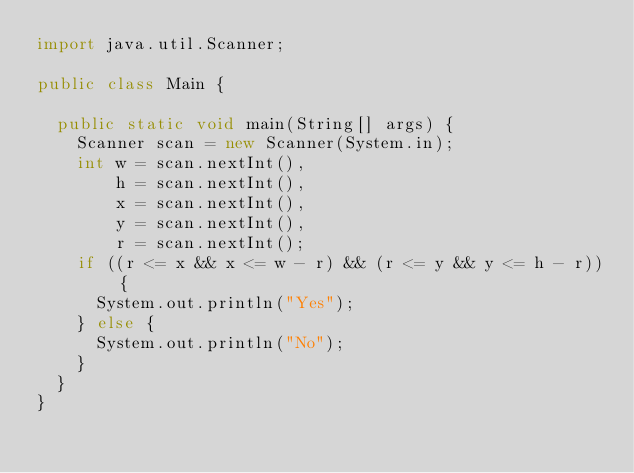<code> <loc_0><loc_0><loc_500><loc_500><_Java_>import java.util.Scanner;

public class Main {

  public static void main(String[] args) {
    Scanner scan = new Scanner(System.in);
    int w = scan.nextInt(),
        h = scan.nextInt(),
        x = scan.nextInt(),
        y = scan.nextInt(),
        r = scan.nextInt();
    if ((r <= x && x <= w - r) && (r <= y && y <= h - r)) {
      System.out.println("Yes");
    } else {
      System.out.println("No");
    }
  }
}
</code> 